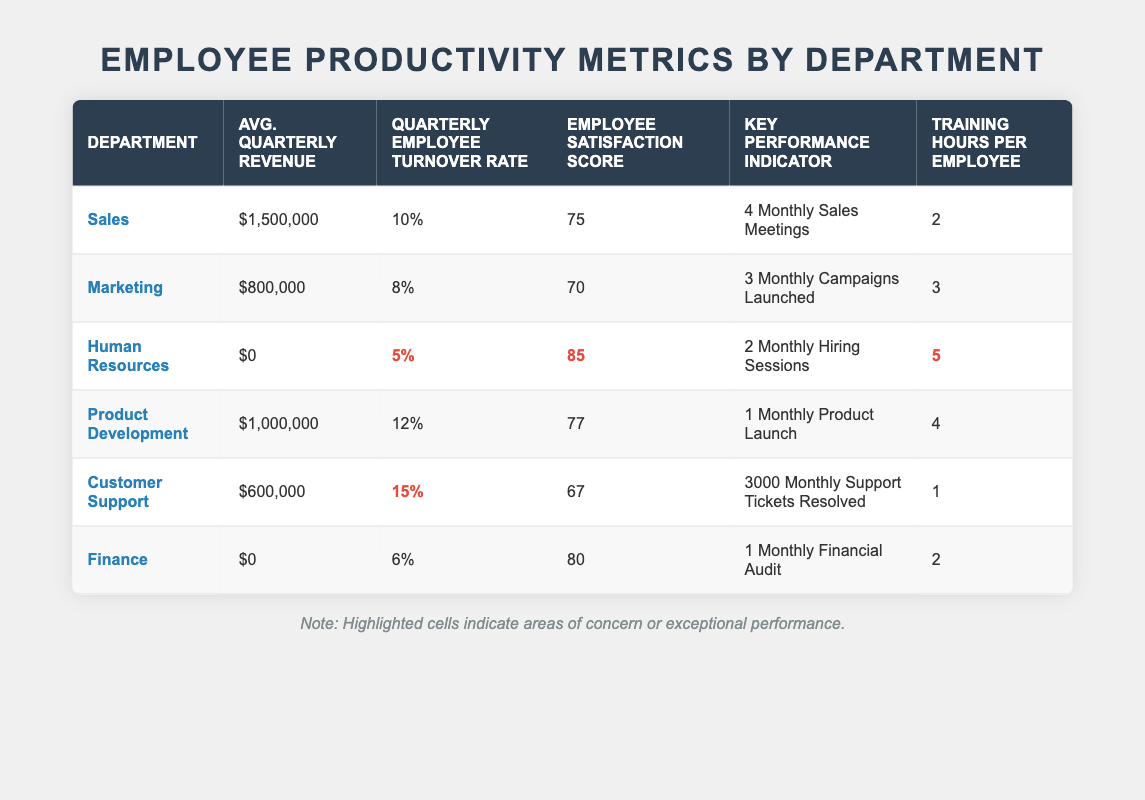What is the average quarterly revenue for the Sales department? The table indicates that the Average Quarterly Revenue for the Sales department is $1,500,000 directly stated in the respective cell.
Answer: $1,500,000 What is the employee satisfaction score for the Human Resources department? The Employee Satisfaction Score for the Human Resources department is listed as 85 in the respective cell of the table.
Answer: 85 Which department has the highest employee turnover rate? By comparing the Quarterly Employee Turnover Rates, the Customer Support department has the highest rate at 15%, which is highlighted in the table.
Answer: Customer Support What is the difference in employee satisfaction scores between the Product Development and Marketing departments? The Product Development department has a score of 77 and the Marketing department has a score of 70. The difference is 77 - 70 = 7.
Answer: 7 Are there any departments with an average quarterly revenue of $0? Looking at the table, both the Human Resources and Finance departments show an average quarterly revenue of $0.
Answer: Yes Which department has the highest training hours per employee? The table shows that the Human Resources department has the highest training hours per employee at 5.
Answer: Human Resources What is the average employee satisfaction score across all departments? The average can be calculated by adding all the employee satisfaction scores (75 + 70 + 85 + 77 + 67 + 80 = 454) and then dividing by the number of departments (6): 454 / 6 = 75.67.
Answer: 75.67 Does the Finance department have a higher turnover rate than the Marketing department? The Finance department has a turnover rate of 6% and the Marketing department has a rate of 8%. Since 6% is less than 8%, Finance does not have a higher turnover rate.
Answer: No Which department has both the lowest employee satisfaction score and the highest turnover rate? The Customer Support department has the lowest employee satisfaction score at 67 and the highest turnover rate at 15%, making it the only department with both conditions.
Answer: Customer Support If the Sales department were to increase its average quarterly revenue by 10%, what would the new revenue amount be? The current average quarterly revenue is $1,500,000. A 10% increase would be 1,500,000 * 0.10 = $150,000. Adding this to the current revenue gives 1,500,000 + 150,000 = $1,650,000.
Answer: $1,650,000 